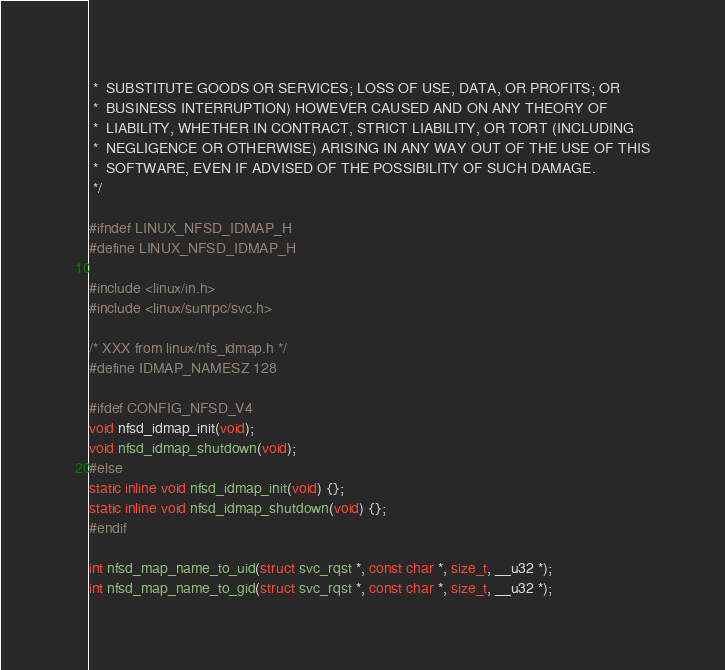<code> <loc_0><loc_0><loc_500><loc_500><_C_> *  SUBSTITUTE GOODS OR SERVICES; LOSS OF USE, DATA, OR PROFITS; OR
 *  BUSINESS INTERRUPTION) HOWEVER CAUSED AND ON ANY THEORY OF
 *  LIABILITY, WHETHER IN CONTRACT, STRICT LIABILITY, OR TORT (INCLUDING
 *  NEGLIGENCE OR OTHERWISE) ARISING IN ANY WAY OUT OF THE USE OF THIS
 *  SOFTWARE, EVEN IF ADVISED OF THE POSSIBILITY OF SUCH DAMAGE.
 */

#ifndef LINUX_NFSD_IDMAP_H
#define LINUX_NFSD_IDMAP_H

#include <linux/in.h>
#include <linux/sunrpc/svc.h>

/* XXX from linux/nfs_idmap.h */
#define IDMAP_NAMESZ 128

#ifdef CONFIG_NFSD_V4
void nfsd_idmap_init(void);
void nfsd_idmap_shutdown(void);
#else
static inline void nfsd_idmap_init(void) {};
static inline void nfsd_idmap_shutdown(void) {};
#endif

int nfsd_map_name_to_uid(struct svc_rqst *, const char *, size_t, __u32 *);
int nfsd_map_name_to_gid(struct svc_rqst *, const char *, size_t, __u32 *);</code> 